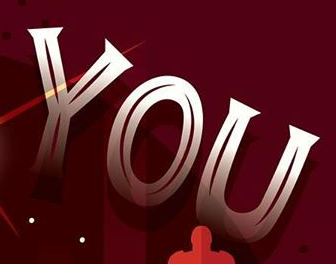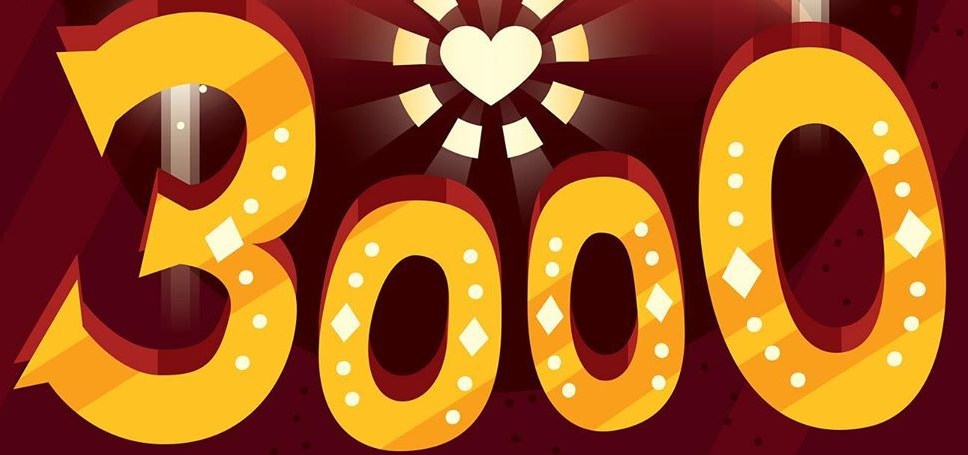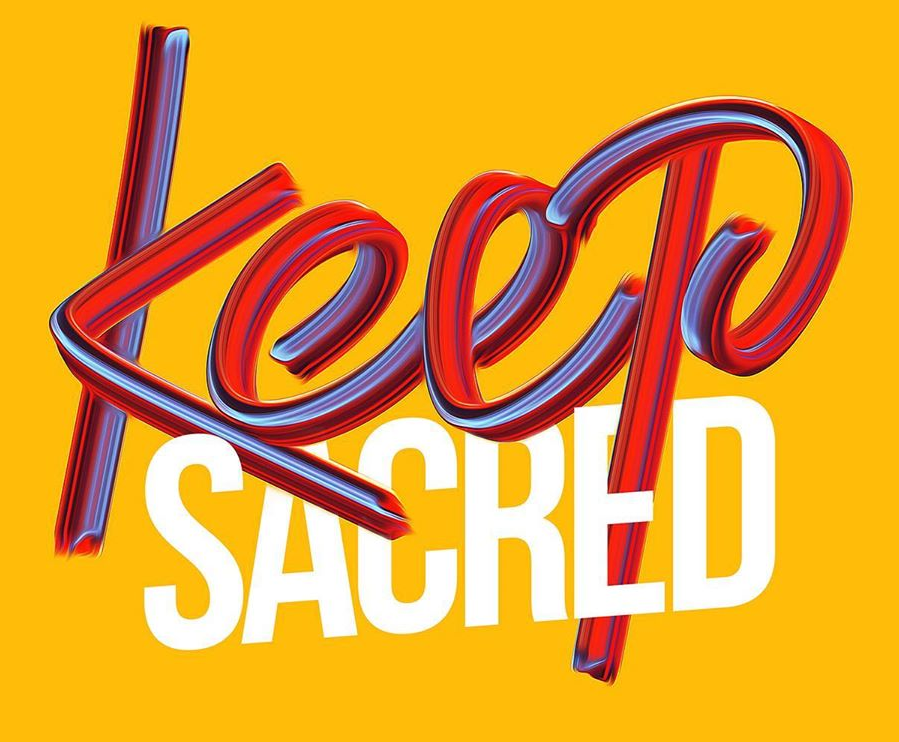Identify the words shown in these images in order, separated by a semicolon. YOU; 3000; Keep 